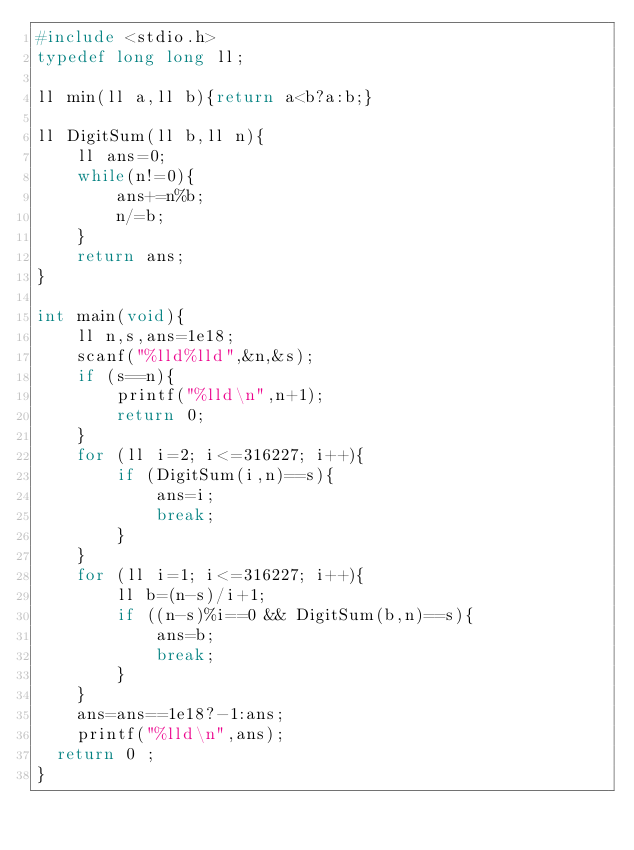<code> <loc_0><loc_0><loc_500><loc_500><_C_>#include <stdio.h>
typedef long long ll;

ll min(ll a,ll b){return a<b?a:b;}

ll DigitSum(ll b,ll n){
    ll ans=0;
    while(n!=0){
        ans+=n%b;
        n/=b;
    }
    return ans;
}

int main(void){
    ll n,s,ans=1e18;
    scanf("%lld%lld",&n,&s);
    if (s==n){
        printf("%lld\n",n+1);
        return 0;
    }
    for (ll i=2; i<=316227; i++){
        if (DigitSum(i,n)==s){
            ans=i;
            break;
        }
    }
    for (ll i=1; i<=316227; i++){
        ll b=(n-s)/i+1;
        if ((n-s)%i==0 && DigitSum(b,n)==s){
            ans=b;
            break;
        }
    }
    ans=ans==1e18?-1:ans;
    printf("%lld\n",ans);
	return 0 ;
}</code> 